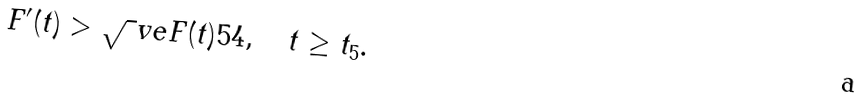<formula> <loc_0><loc_0><loc_500><loc_500>F ^ { \prime } ( t ) > \sqrt { \ } v e F ( t ) ^ { } { 5 } 4 , \quad t \geq t _ { 5 } .</formula> 